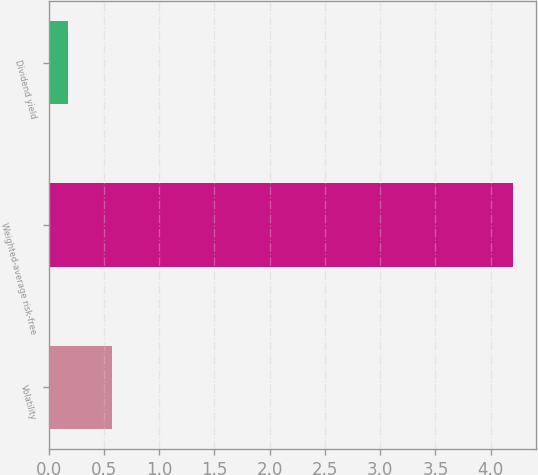<chart> <loc_0><loc_0><loc_500><loc_500><bar_chart><fcel>Volatility<fcel>Weighted-average risk-free<fcel>Dividend yield<nl><fcel>0.57<fcel>4.2<fcel>0.17<nl></chart> 